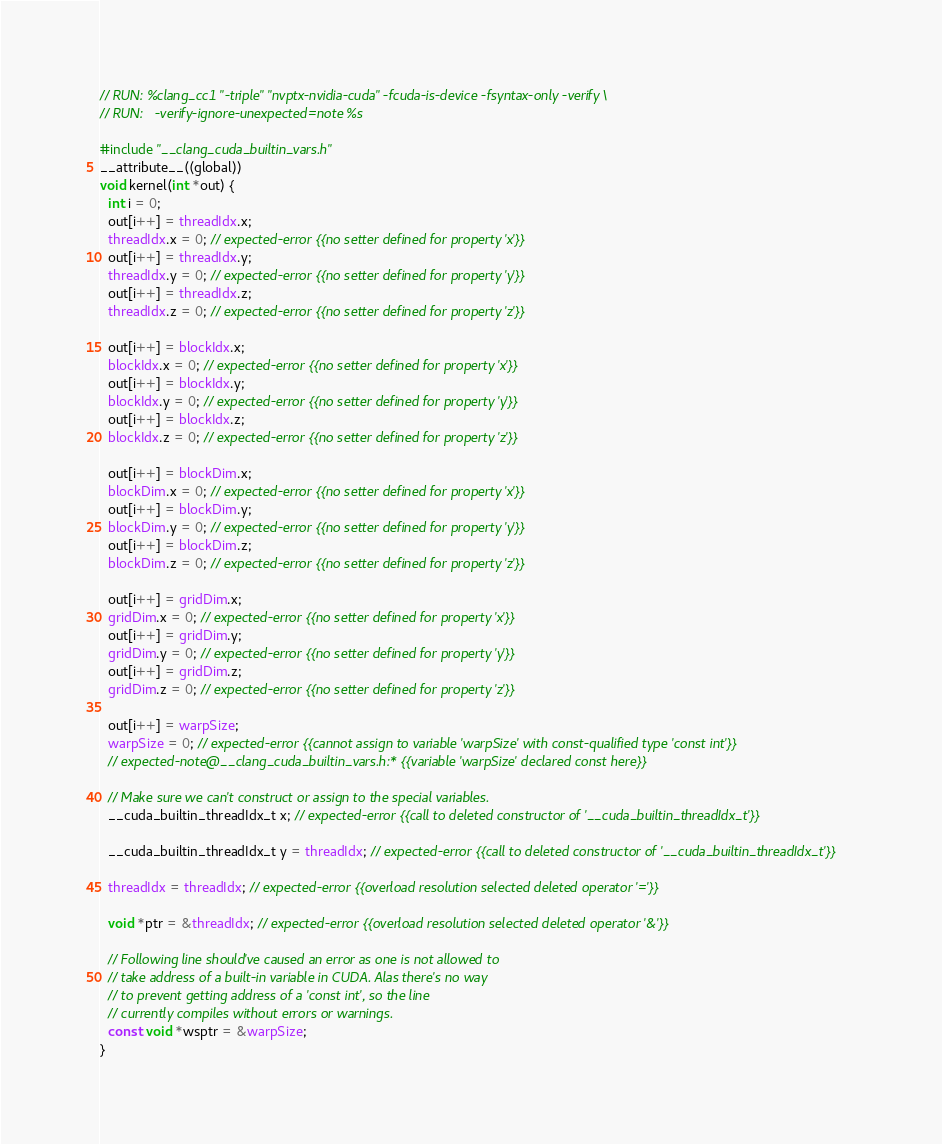Convert code to text. <code><loc_0><loc_0><loc_500><loc_500><_Cuda_>// RUN: %clang_cc1 "-triple" "nvptx-nvidia-cuda" -fcuda-is-device -fsyntax-only -verify \
// RUN:   -verify-ignore-unexpected=note %s

#include "__clang_cuda_builtin_vars.h"
__attribute__((global))
void kernel(int *out) {
  int i = 0;
  out[i++] = threadIdx.x;
  threadIdx.x = 0; // expected-error {{no setter defined for property 'x'}}
  out[i++] = threadIdx.y;
  threadIdx.y = 0; // expected-error {{no setter defined for property 'y'}}
  out[i++] = threadIdx.z;
  threadIdx.z = 0; // expected-error {{no setter defined for property 'z'}}

  out[i++] = blockIdx.x;
  blockIdx.x = 0; // expected-error {{no setter defined for property 'x'}}
  out[i++] = blockIdx.y;
  blockIdx.y = 0; // expected-error {{no setter defined for property 'y'}}
  out[i++] = blockIdx.z;
  blockIdx.z = 0; // expected-error {{no setter defined for property 'z'}}

  out[i++] = blockDim.x;
  blockDim.x = 0; // expected-error {{no setter defined for property 'x'}}
  out[i++] = blockDim.y;
  blockDim.y = 0; // expected-error {{no setter defined for property 'y'}}
  out[i++] = blockDim.z;
  blockDim.z = 0; // expected-error {{no setter defined for property 'z'}}

  out[i++] = gridDim.x;
  gridDim.x = 0; // expected-error {{no setter defined for property 'x'}}
  out[i++] = gridDim.y;
  gridDim.y = 0; // expected-error {{no setter defined for property 'y'}}
  out[i++] = gridDim.z;
  gridDim.z = 0; // expected-error {{no setter defined for property 'z'}}

  out[i++] = warpSize;
  warpSize = 0; // expected-error {{cannot assign to variable 'warpSize' with const-qualified type 'const int'}}
  // expected-note@__clang_cuda_builtin_vars.h:* {{variable 'warpSize' declared const here}}

  // Make sure we can't construct or assign to the special variables.
  __cuda_builtin_threadIdx_t x; // expected-error {{call to deleted constructor of '__cuda_builtin_threadIdx_t'}}

  __cuda_builtin_threadIdx_t y = threadIdx; // expected-error {{call to deleted constructor of '__cuda_builtin_threadIdx_t'}}

  threadIdx = threadIdx; // expected-error {{overload resolution selected deleted operator '='}}

  void *ptr = &threadIdx; // expected-error {{overload resolution selected deleted operator '&'}}

  // Following line should've caused an error as one is not allowed to
  // take address of a built-in variable in CUDA. Alas there's no way
  // to prevent getting address of a 'const int', so the line
  // currently compiles without errors or warnings.
  const void *wsptr = &warpSize;
}
</code> 